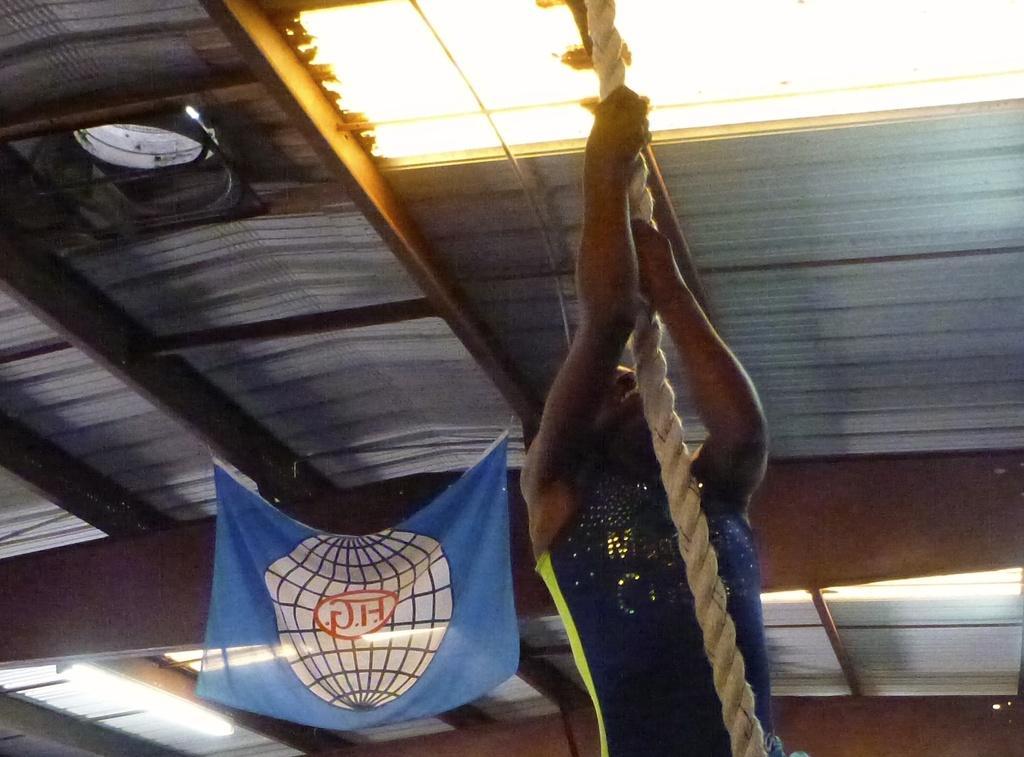Could you give a brief overview of what you see in this image? In this picture there is a person holding the roof. At the top there are lights and there is a roof. At the back there is a banner on the roof. 